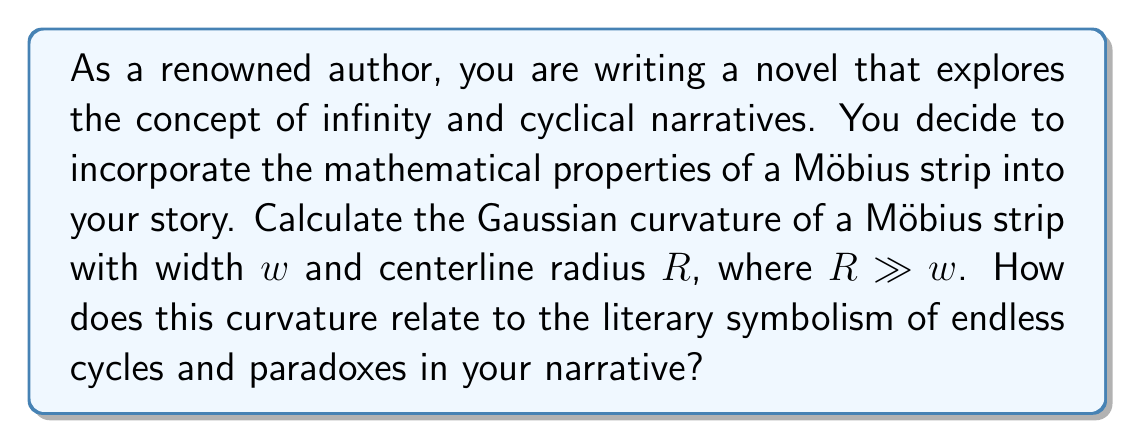Show me your answer to this math problem. To determine the Gaussian curvature of a Möbius strip, we need to consider its unique topological properties and geometric structure.

1. Parameterization of the Möbius strip:
   Let's parameterize the Möbius strip using the following equations:
   $$x(u,v) = (R + v\cos(\frac{u}{2}))\cos(u)$$
   $$y(u,v) = (R + v\cos(\frac{u}{2}))\sin(u)$$
   $$z(u,v) = v\sin(\frac{u}{2})$$
   where $u \in [0, 2\pi]$ and $v \in [-\frac{w}{2}, \frac{w}{2}]$

2. Calculate the first fundamental form:
   We need to compute $E$, $F$, and $G$:
   $$E = \left(\frac{\partial x}{\partial u}\right)^2 + \left(\frac{\partial y}{\partial u}\right)^2 + \left(\frac{\partial z}{\partial u}\right)^2$$
   $$F = \frac{\partial x}{\partial u}\frac{\partial x}{\partial v} + \frac{\partial y}{\partial u}\frac{\partial y}{\partial v} + \frac{\partial z}{\partial u}\frac{\partial z}{\partial v}$$
   $$G = \left(\frac{\partial x}{\partial v}\right)^2 + \left(\frac{\partial y}{\partial v}\right)^2 + \left(\frac{\partial z}{\partial v}\right)^2$$

3. Calculate the second fundamental form:
   We need to compute $L$, $M$, and $N$ using the normal vector $\mathbf{n}$:
   $$L = \mathbf{n} \cdot \frac{\partial^2\mathbf{r}}{\partial u^2}$$
   $$M = \mathbf{n} \cdot \frac{\partial^2\mathbf{r}}{\partial u\partial v}$$
   $$N = \mathbf{n} \cdot \frac{\partial^2\mathbf{r}}{\partial v^2}$$

4. Compute the Gaussian curvature:
   The Gaussian curvature $K$ is given by:
   $$K = \frac{LN - M^2}{EG - F^2}$$

5. Simplify the expression:
   Given that $R \gg w$, we can approximate the Gaussian curvature as:
   $$K \approx -\frac{\cos(\frac{u}{2})}{R(R + v\cos(\frac{u}{2}))}$$

6. Analyze the result:
   The Gaussian curvature varies along the strip but is generally negative. At the centerline ($v = 0$), it simplifies to:
   $$K \approx -\frac{\cos(\frac{u}{2})}{R^2}$$

   This negative curvature relates to the literary symbolism of endless cycles and paradoxes in several ways:
   
   a) The negative curvature creates a hyperbolic geometry, which can represent the complex, non-Euclidean nature of narrative structures.
   
   b) The varying curvature along the strip symbolizes the changing perspectives and interpretations throughout a cyclical narrative.
   
   c) The fact that the curvature is non-zero everywhere except at specific points (where $\cos(\frac{u}{2}) = 0$) reflects the constant tension and movement in a paradoxical or cyclical story.
   
   d) The periodicity of the curvature ($K(u) = K(u + 4\pi)$) mirrors the repetitive yet evolving nature of cyclical narratives.
Answer: The approximate Gaussian curvature of a Möbius strip with width $w$ and centerline radius $R$, where $R \gg w$, is:

$$K \approx -\frac{\cos(\frac{u}{2})}{R(R + v\cos(\frac{u}{2}))}$$

This negative, varying curvature symbolizes the complex, non-Euclidean nature of cyclical narratives, representing changing perspectives, constant tension, and the repetitive yet evolving structure of paradoxical storytelling. 